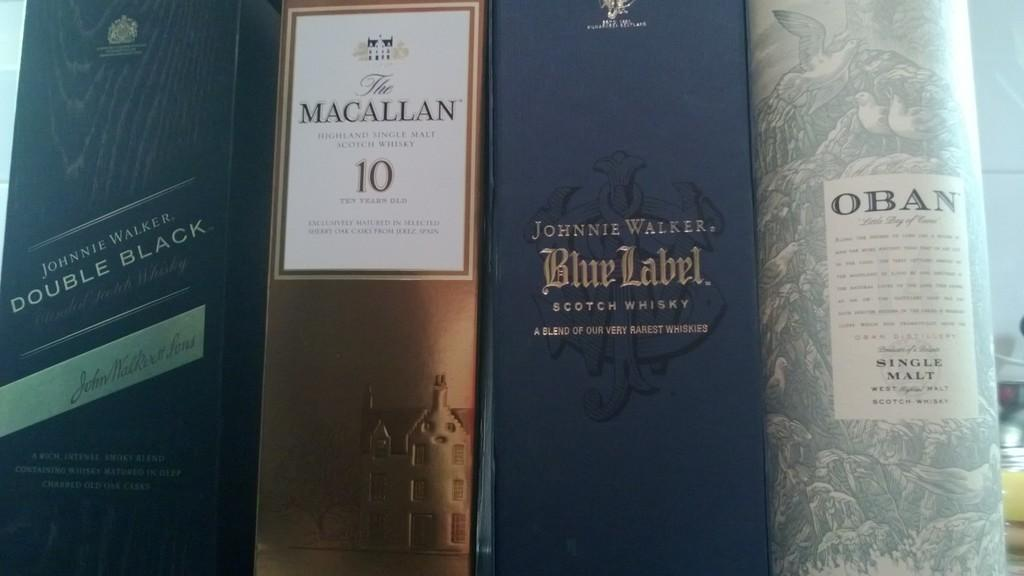<image>
Render a clear and concise summary of the photo. A collection of four boxed whiskeys include Macallan 10 and Johnnie Walker Blue. 